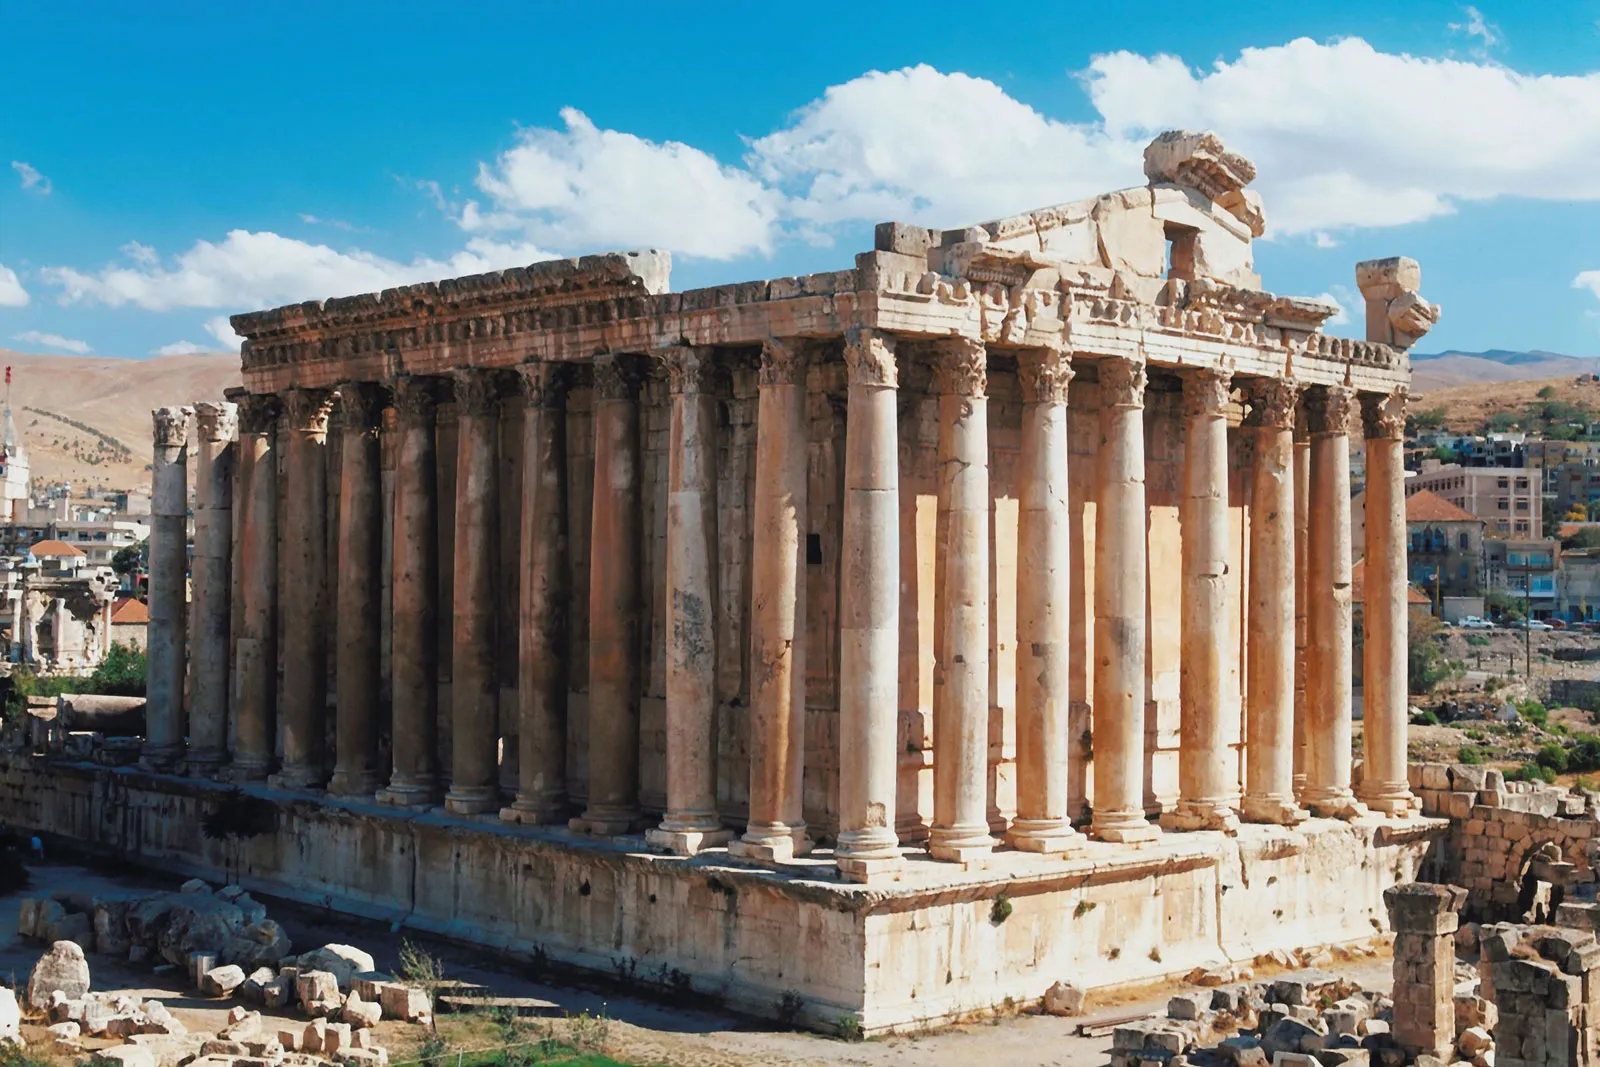Can you tell me more about the history of the Temple of Jupiter? Certainly! The Temple of Jupiter, part of the ancient city of Baalbek in Lebanon, is a marvel of Roman architecture and engineering. It was constructed during the 1st century AD when the city was known as Heliopolis. The temple was the largest sanctuary dedicated to Jupiter, and its construction likely spanned over a century. It was an important religious site and also served as a demonstration of Roman power and cultural influence in the region. 